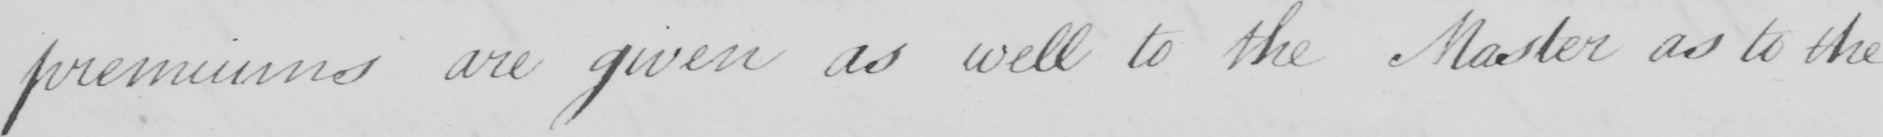What text is written in this handwritten line? premiums are given as well to the Master as to the 